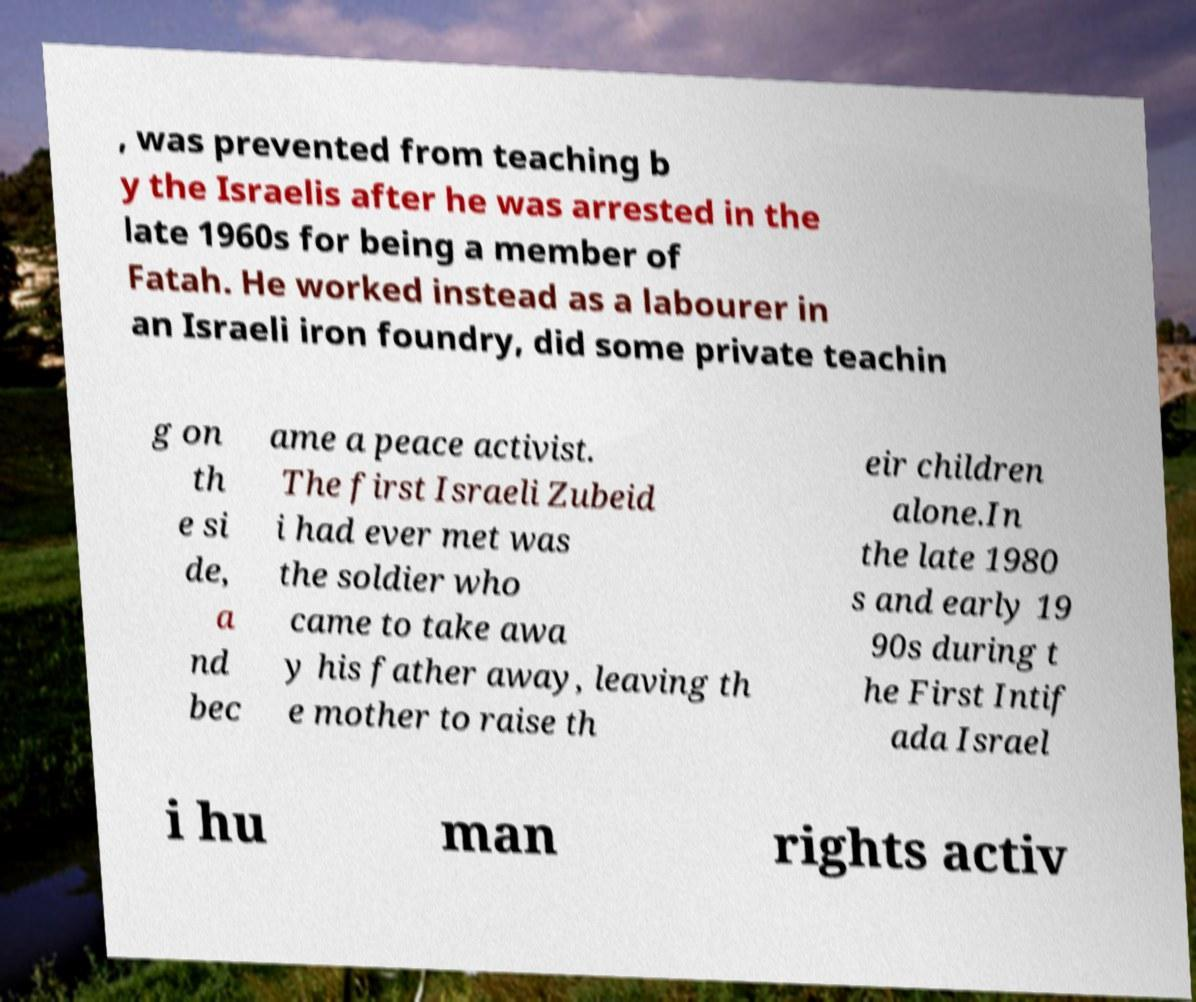Can you read and provide the text displayed in the image?This photo seems to have some interesting text. Can you extract and type it out for me? , was prevented from teaching b y the Israelis after he was arrested in the late 1960s for being a member of Fatah. He worked instead as a labourer in an Israeli iron foundry, did some private teachin g on th e si de, a nd bec ame a peace activist. The first Israeli Zubeid i had ever met was the soldier who came to take awa y his father away, leaving th e mother to raise th eir children alone.In the late 1980 s and early 19 90s during t he First Intif ada Israel i hu man rights activ 